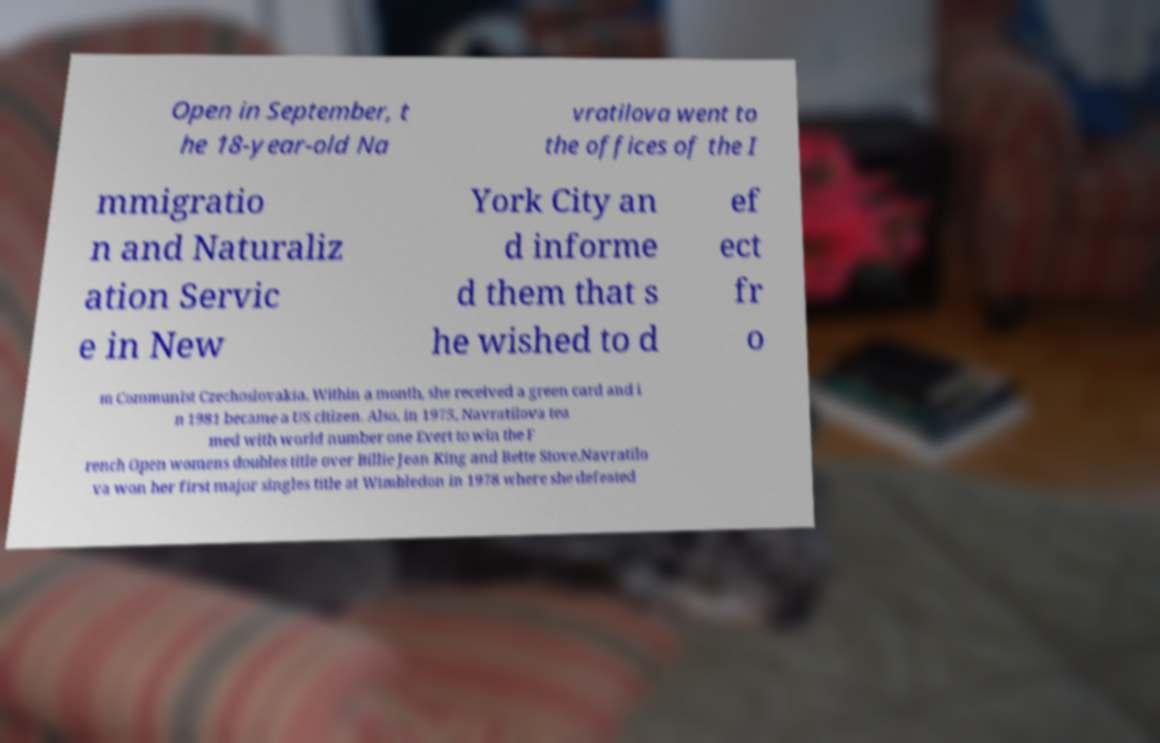For documentation purposes, I need the text within this image transcribed. Could you provide that? Open in September, t he 18-year-old Na vratilova went to the offices of the I mmigratio n and Naturaliz ation Servic e in New York City an d informe d them that s he wished to d ef ect fr o m Communist Czechoslovakia. Within a month, she received a green card and i n 1981 became a US citizen. Also, in 1975, Navratilova tea med with world number one Evert to win the F rench Open womens doubles title over Billie Jean King and Bette Stove.Navratilo va won her first major singles title at Wimbledon in 1978 where she defeated 